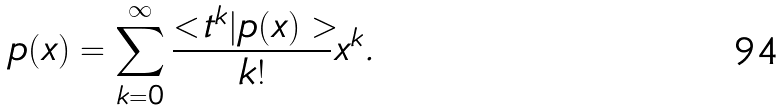Convert formula to latex. <formula><loc_0><loc_0><loc_500><loc_500>p ( x ) = \sum _ { k = 0 } ^ { \infty } \frac { < t ^ { k } | p ( x ) > } { k ! } x ^ { k } .</formula> 